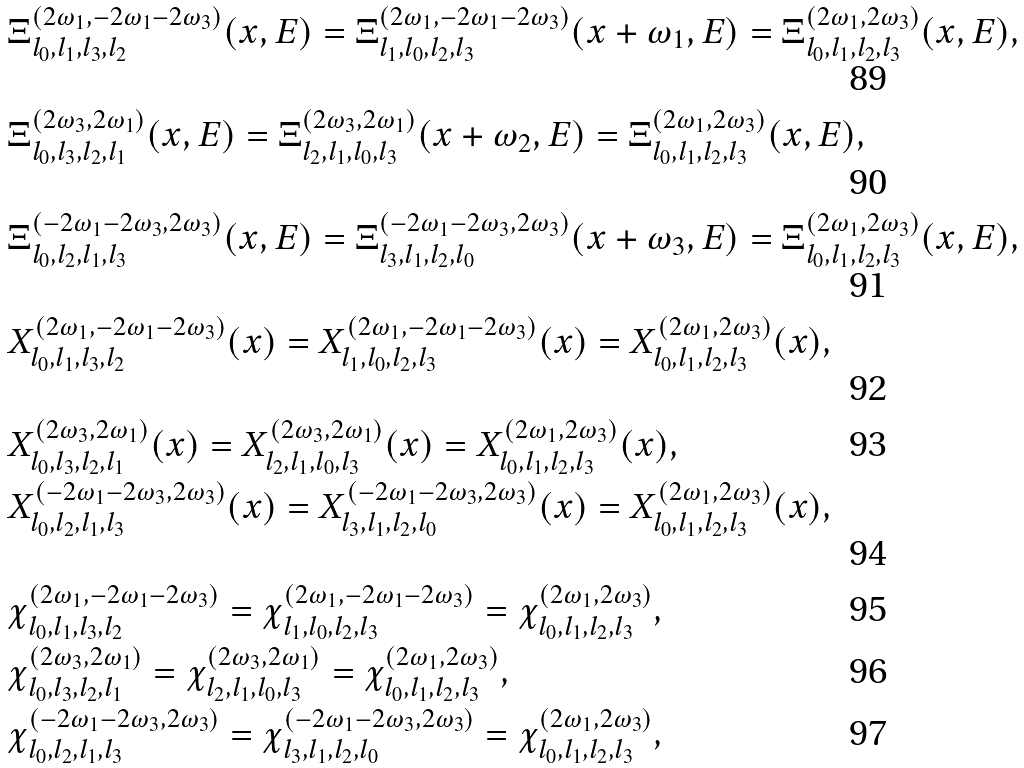<formula> <loc_0><loc_0><loc_500><loc_500>& \Xi _ { l _ { 0 } , l _ { 1 } , l _ { 3 } , l _ { 2 } } ^ { ( 2 \omega _ { 1 } , - 2 \omega _ { 1 } - 2 \omega _ { 3 } ) } ( x , E ) = \Xi _ { l _ { 1 } , l _ { 0 } , l _ { 2 } , l _ { 3 } } ^ { ( 2 \omega _ { 1 } , - 2 \omega _ { 1 } - 2 \omega _ { 3 } ) } ( x + \omega _ { 1 } , E ) = \Xi _ { l _ { 0 } , l _ { 1 } , l _ { 2 } , l _ { 3 } } ^ { ( 2 \omega _ { 1 } , 2 \omega _ { 3 } ) } ( x , E ) , \\ & \Xi _ { l _ { 0 } , l _ { 3 } , l _ { 2 } , l _ { 1 } } ^ { ( 2 \omega _ { 3 } , 2 \omega _ { 1 } ) } ( x , E ) = \Xi _ { l _ { 2 } , l _ { 1 } , l _ { 0 } , l _ { 3 } } ^ { ( 2 \omega _ { 3 } , 2 \omega _ { 1 } ) } ( x + \omega _ { 2 } , E ) = \Xi _ { l _ { 0 } , l _ { 1 } , l _ { 2 } , l _ { 3 } } ^ { ( 2 \omega _ { 1 } , 2 \omega _ { 3 } ) } ( x , E ) , \\ & \Xi _ { l _ { 0 } , l _ { 2 } , l _ { 1 } , l _ { 3 } } ^ { ( - 2 \omega _ { 1 } - 2 \omega _ { 3 } , 2 \omega _ { 3 } ) } ( x , E ) = \Xi _ { l _ { 3 } , l _ { 1 } , l _ { 2 } , l _ { 0 } } ^ { ( - 2 \omega _ { 1 } - 2 \omega _ { 3 } , 2 \omega _ { 3 } ) } ( x + \omega _ { 3 } , E ) = \Xi _ { l _ { 0 } , l _ { 1 } , l _ { 2 } , l _ { 3 } } ^ { ( 2 \omega _ { 1 } , 2 \omega _ { 3 } ) } ( x , E ) , \\ & X _ { l _ { 0 } , l _ { 1 } , l _ { 3 } , l _ { 2 } } ^ { ( 2 \omega _ { 1 } , - 2 \omega _ { 1 } - 2 \omega _ { 3 } ) } ( x ) = X _ { l _ { 1 } , l _ { 0 } , l _ { 2 } , l _ { 3 } } ^ { ( 2 \omega _ { 1 } , - 2 \omega _ { 1 } - 2 \omega _ { 3 } ) } ( x ) = X _ { l _ { 0 } , l _ { 1 } , l _ { 2 } , l _ { 3 } } ^ { ( 2 \omega _ { 1 } , 2 \omega _ { 3 } ) } ( x ) , \\ & X _ { l _ { 0 } , l _ { 3 } , l _ { 2 } , l _ { 1 } } ^ { ( 2 \omega _ { 3 } , 2 \omega _ { 1 } ) } ( x ) = X _ { l _ { 2 } , l _ { 1 } , l _ { 0 } , l _ { 3 } } ^ { ( 2 \omega _ { 3 } , 2 \omega _ { 1 } ) } ( x ) = X _ { l _ { 0 } , l _ { 1 } , l _ { 2 } , l _ { 3 } } ^ { ( 2 \omega _ { 1 } , 2 \omega _ { 3 } ) } ( x ) , \\ & X _ { l _ { 0 } , l _ { 2 } , l _ { 1 } , l _ { 3 } } ^ { ( - 2 \omega _ { 1 } - 2 \omega _ { 3 } , 2 \omega _ { 3 } ) } ( x ) = X _ { l _ { 3 } , l _ { 1 } , l _ { 2 } , l _ { 0 } } ^ { ( - 2 \omega _ { 1 } - 2 \omega _ { 3 } , 2 \omega _ { 3 } ) } ( x ) = X _ { l _ { 0 } , l _ { 1 } , l _ { 2 } , l _ { 3 } } ^ { ( 2 \omega _ { 1 } , 2 \omega _ { 3 } ) } ( x ) , \\ & \chi _ { l _ { 0 } , l _ { 1 } , l _ { 3 } , l _ { 2 } } ^ { ( 2 \omega _ { 1 } , - 2 \omega _ { 1 } - 2 \omega _ { 3 } ) } = \chi _ { l _ { 1 } , l _ { 0 } , l _ { 2 } , l _ { 3 } } ^ { ( 2 \omega _ { 1 } , - 2 \omega _ { 1 } - 2 \omega _ { 3 } ) } = \chi _ { l _ { 0 } , l _ { 1 } , l _ { 2 } , l _ { 3 } } ^ { ( 2 \omega _ { 1 } , 2 \omega _ { 3 } ) } , \\ & \chi _ { l _ { 0 } , l _ { 3 } , l _ { 2 } , l _ { 1 } } ^ { ( 2 \omega _ { 3 } , 2 \omega _ { 1 } ) } = \chi _ { l _ { 2 } , l _ { 1 } , l _ { 0 } , l _ { 3 } } ^ { ( 2 \omega _ { 3 } , 2 \omega _ { 1 } ) } = \chi _ { l _ { 0 } , l _ { 1 } , l _ { 2 } , l _ { 3 } } ^ { ( 2 \omega _ { 1 } , 2 \omega _ { 3 } ) } , \\ & \chi _ { l _ { 0 } , l _ { 2 } , l _ { 1 } , l _ { 3 } } ^ { ( - 2 \omega _ { 1 } - 2 \omega _ { 3 } , 2 \omega _ { 3 } ) } = \chi _ { l _ { 3 } , l _ { 1 } , l _ { 2 } , l _ { 0 } } ^ { ( - 2 \omega _ { 1 } - 2 \omega _ { 3 } , 2 \omega _ { 3 } ) } = \chi _ { l _ { 0 } , l _ { 1 } , l _ { 2 } , l _ { 3 } } ^ { ( 2 \omega _ { 1 } , 2 \omega _ { 3 } ) } ,</formula> 